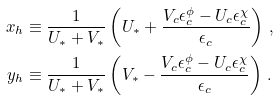<formula> <loc_0><loc_0><loc_500><loc_500>x _ { h } & \equiv \frac { 1 } { U _ { * } + V _ { * } } \left ( U _ { * } + \frac { V _ { c } \epsilon _ { c } ^ { \phi } - U _ { c } \epsilon _ { c } ^ { \chi } } { \epsilon _ { c } } \right ) \, , \\ y _ { h } & \equiv \frac { 1 } { U _ { * } + V _ { * } } \left ( V _ { * } - \frac { V _ { c } \epsilon _ { c } ^ { \phi } - U _ { c } \epsilon _ { c } ^ { \chi } } { \epsilon _ { c } } \right ) \, .</formula> 